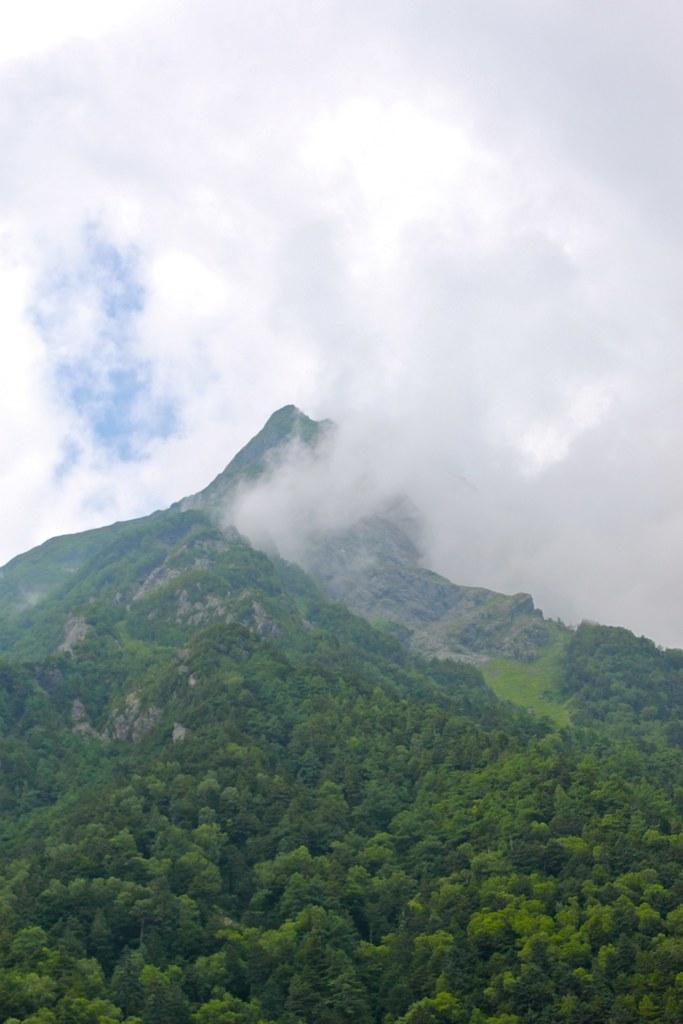What type of natural features can be seen in the image? There are trees and mountains in the image. What part of the natural environment is visible in the image? The sky is visible in the image. What type of apparel is being worn by the trees in the image? There are no people or apparel present in the image, as it features trees, mountains, and the sky. 